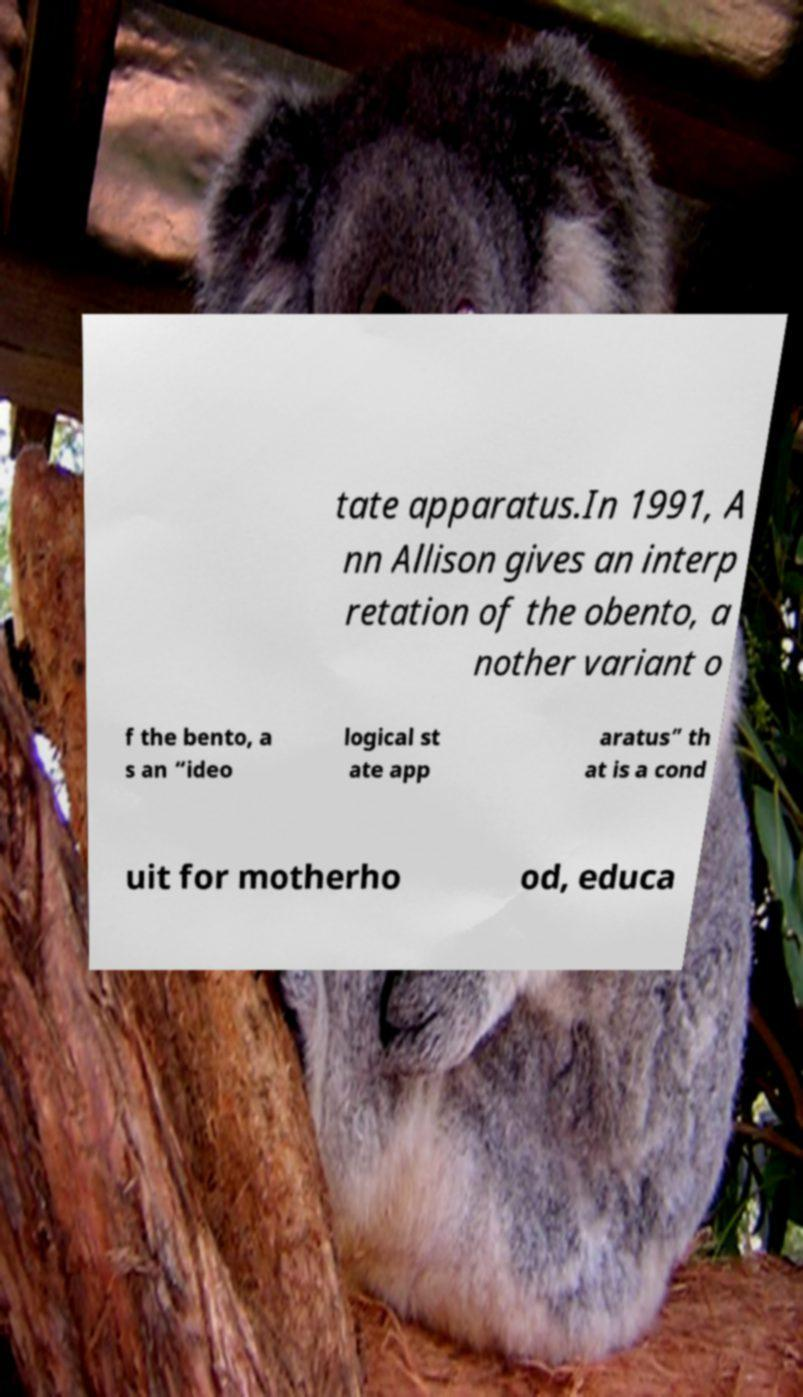Could you extract and type out the text from this image? tate apparatus.In 1991, A nn Allison gives an interp retation of the obento, a nother variant o f the bento, a s an “ideo logical st ate app aratus” th at is a cond uit for motherho od, educa 